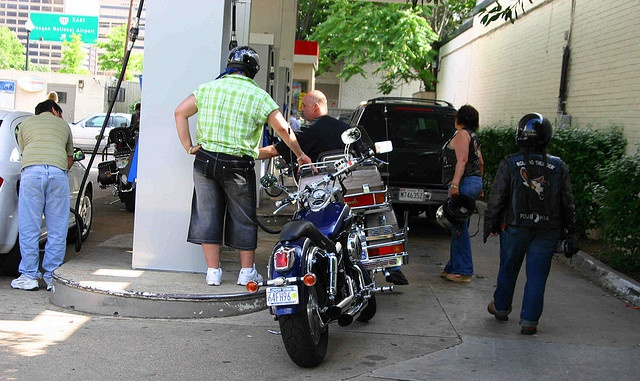Describe the objects in this image and their specific colors. I can see motorcycle in pink, black, gray, white, and navy tones, people in pink, black, ivory, gray, and lightgreen tones, people in pink, black, gray, navy, and maroon tones, people in pink, darkgray, gray, and lightblue tones, and truck in pink, black, gray, darkgray, and maroon tones in this image. 